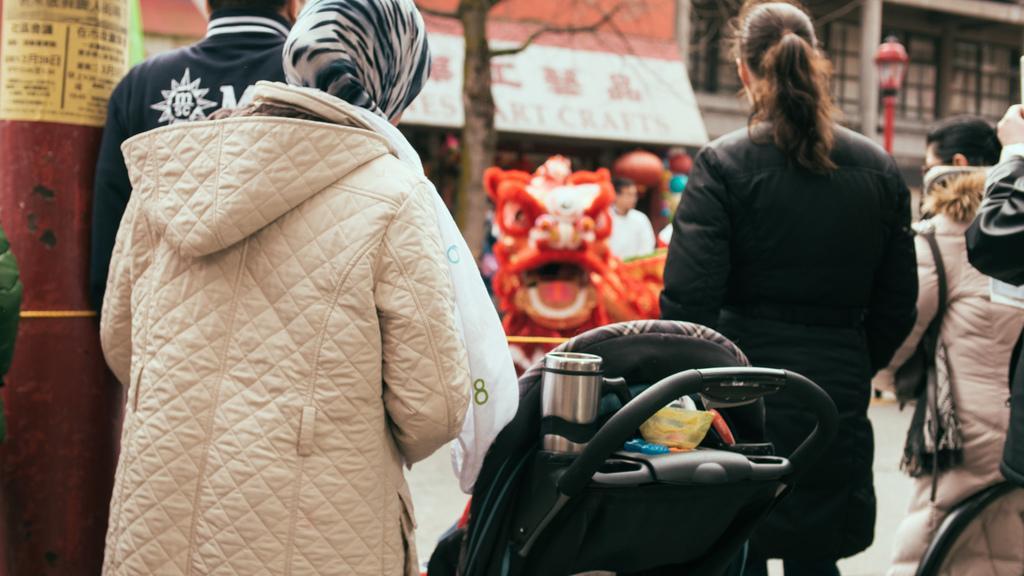Can you describe this image briefly? This image consists of two women wearing jacket. In the middle, there is a trolley. In the background, there are houses along with a tree. At the bottom, there is a road. 